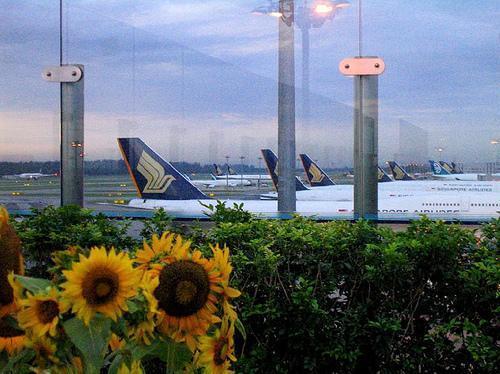How many planes have red tails at the back?
Give a very brief answer. 0. 